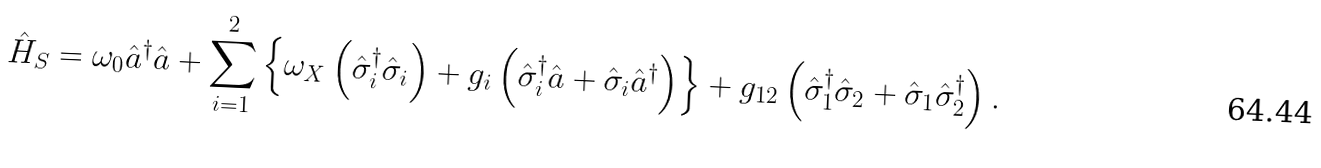Convert formula to latex. <formula><loc_0><loc_0><loc_500><loc_500>\hat { H } _ { S } = \omega _ { 0 } \hat { a } ^ { \dagger } \hat { a } + \sum _ { i = 1 } ^ { 2 } \left \{ \omega _ { X } \left ( \hat { \sigma } _ { i } ^ { \dagger } \hat { \sigma } _ { i } \right ) + g _ { i } \left ( \hat { \sigma } ^ { \dagger } _ { i } \hat { a } + \hat { \sigma } _ { i } \hat { a } ^ { \dagger } \right ) \right \} + g _ { 1 2 } \left ( \hat { \sigma } _ { 1 } ^ { \dagger } \hat { \sigma } _ { 2 } + \hat { \sigma } _ { 1 } \hat { \sigma } _ { 2 } ^ { \dagger } \right ) .</formula> 